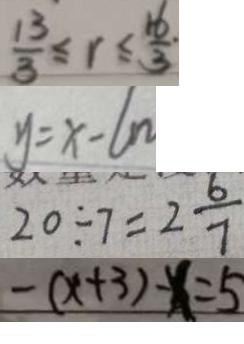<formula> <loc_0><loc_0><loc_500><loc_500>\frac { 1 3 } { 3 } \leq r \leq \frac { 1 6 } { 3 } 
 y = x - 6 n 
 2 0 \div 7 = 2 \frac { 6 } { 7 } 
 - ( x + 3 ) - x = 5</formula> 